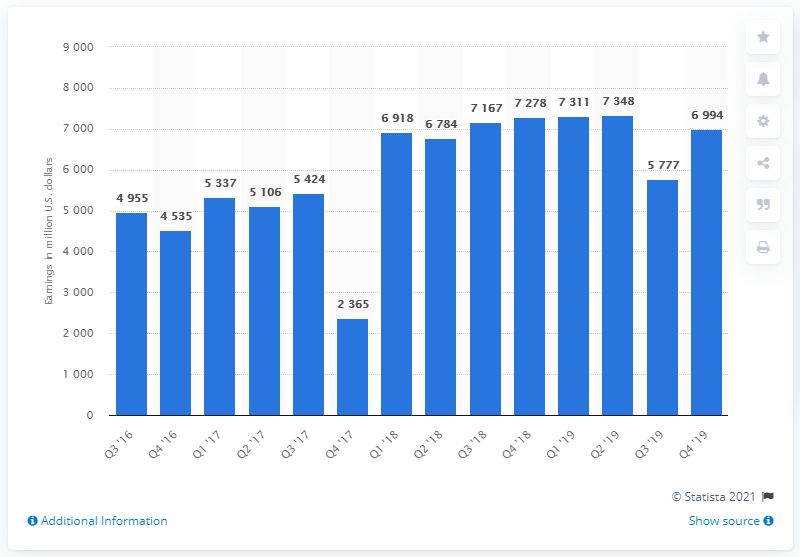Specify some key components in this picture. In the fourth quarter of 2019, the net income of Bank of America was 6994. 